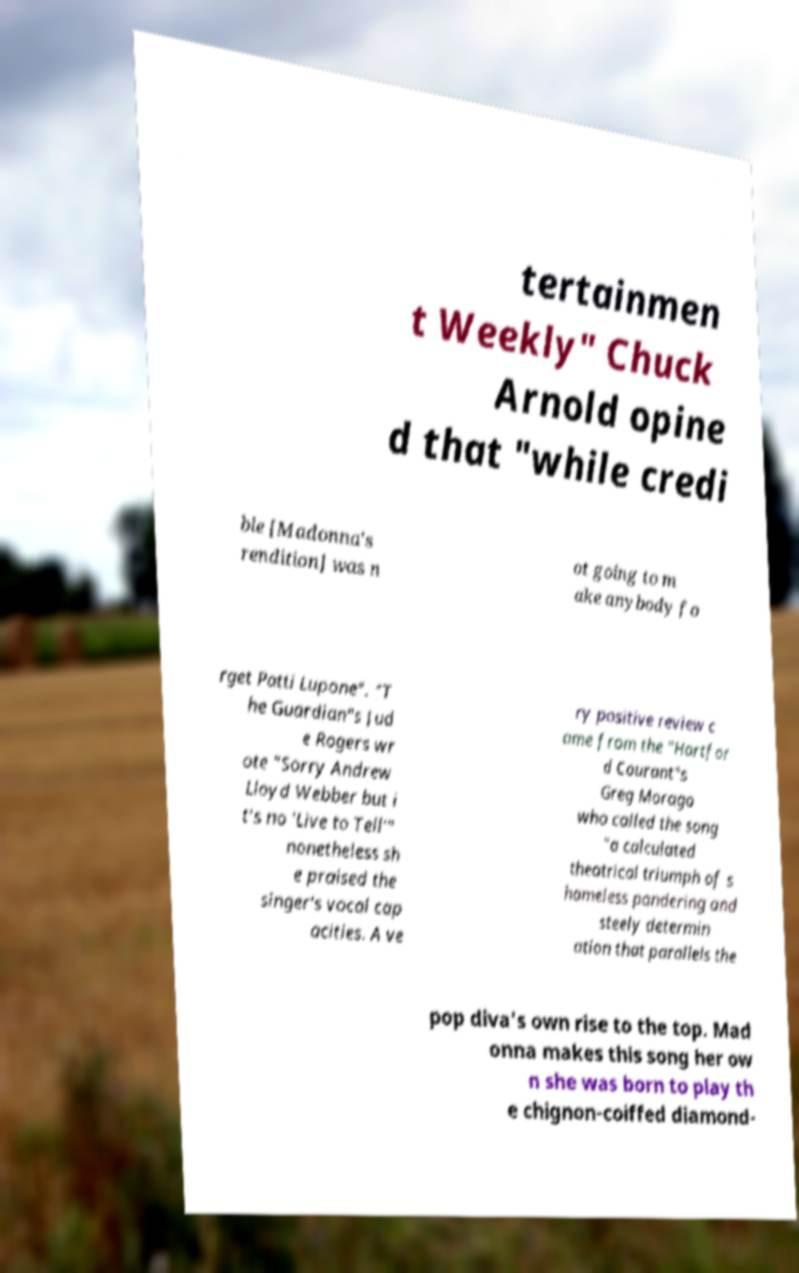Can you accurately transcribe the text from the provided image for me? tertainmen t Weekly" Chuck Arnold opine d that "while credi ble [Madonna's rendition] was n ot going to m ake anybody fo rget Patti Lupone". "T he Guardian"s Jud e Rogers wr ote "Sorry Andrew Lloyd Webber but i t's no 'Live to Tell'" nonetheless sh e praised the singer's vocal cap acities. A ve ry positive review c ame from the "Hartfor d Courant"s Greg Morago who called the song "a calculated theatrical triumph of s hameless pandering and steely determin ation that parallels the pop diva's own rise to the top. Mad onna makes this song her ow n she was born to play th e chignon-coiffed diamond- 